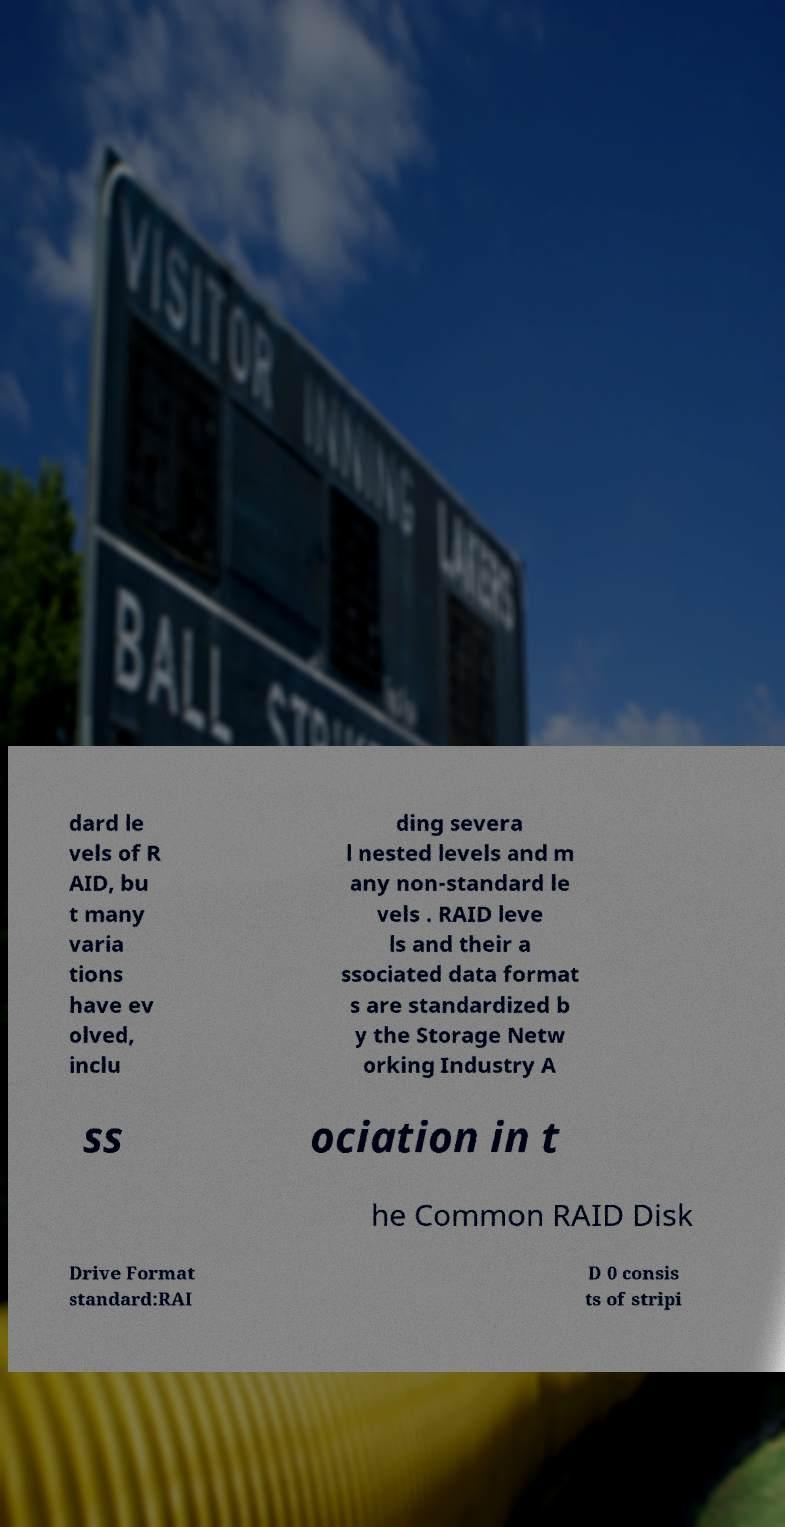Please identify and transcribe the text found in this image. dard le vels of R AID, bu t many varia tions have ev olved, inclu ding severa l nested levels and m any non-standard le vels . RAID leve ls and their a ssociated data format s are standardized b y the Storage Netw orking Industry A ss ociation in t he Common RAID Disk Drive Format standard:RAI D 0 consis ts of stripi 